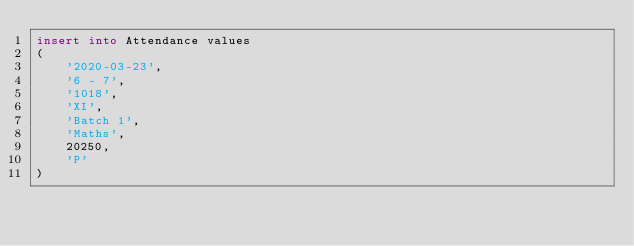<code> <loc_0><loc_0><loc_500><loc_500><_SQL_>insert into Attendance values
(
	'2020-03-23',
	'6 - 7',
	'1018',
	'XI',
	'Batch 1',
	'Maths',
	20250,
	'P'
)</code> 